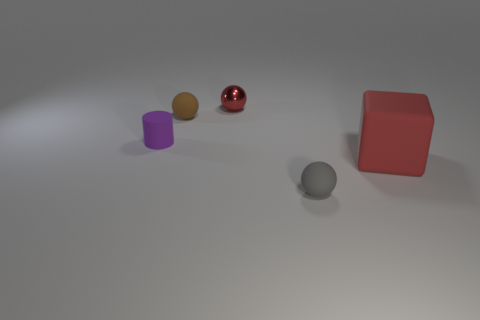Add 5 small spheres. How many objects exist? 10 Subtract all cylinders. How many objects are left? 4 Subtract all large red rubber cubes. Subtract all purple rubber cylinders. How many objects are left? 3 Add 4 large things. How many large things are left? 5 Add 2 gray rubber cylinders. How many gray rubber cylinders exist? 2 Subtract 0 cyan blocks. How many objects are left? 5 